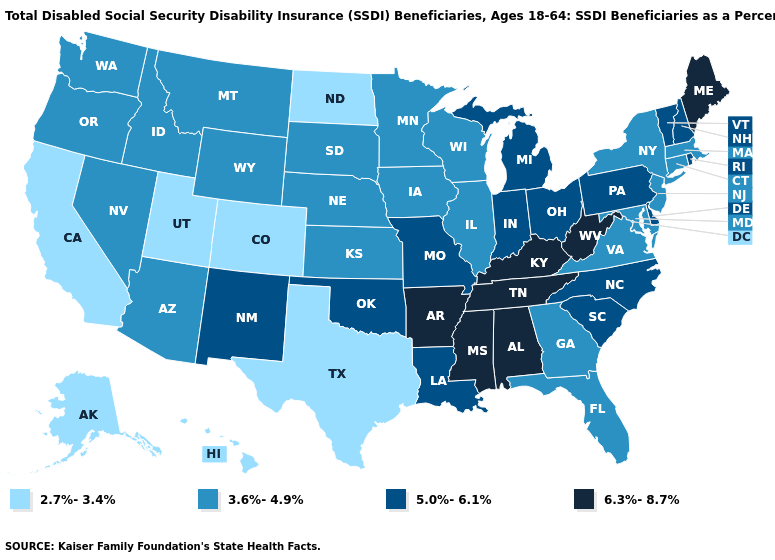Name the states that have a value in the range 6.3%-8.7%?
Concise answer only. Alabama, Arkansas, Kentucky, Maine, Mississippi, Tennessee, West Virginia. What is the lowest value in the Northeast?
Short answer required. 3.6%-4.9%. What is the value of Alaska?
Concise answer only. 2.7%-3.4%. Does Delaware have a lower value than Mississippi?
Keep it brief. Yes. How many symbols are there in the legend?
Be succinct. 4. How many symbols are there in the legend?
Give a very brief answer. 4. Name the states that have a value in the range 5.0%-6.1%?
Concise answer only. Delaware, Indiana, Louisiana, Michigan, Missouri, New Hampshire, New Mexico, North Carolina, Ohio, Oklahoma, Pennsylvania, Rhode Island, South Carolina, Vermont. Which states hav the highest value in the West?
Give a very brief answer. New Mexico. Does New Hampshire have the same value as New Mexico?
Quick response, please. Yes. Does Rhode Island have the same value as Colorado?
Give a very brief answer. No. What is the lowest value in states that border Florida?
Keep it brief. 3.6%-4.9%. Does New Jersey have a higher value than California?
Write a very short answer. Yes. Does the first symbol in the legend represent the smallest category?
Quick response, please. Yes. What is the highest value in the USA?
Be succinct. 6.3%-8.7%. What is the lowest value in the USA?
Keep it brief. 2.7%-3.4%. 